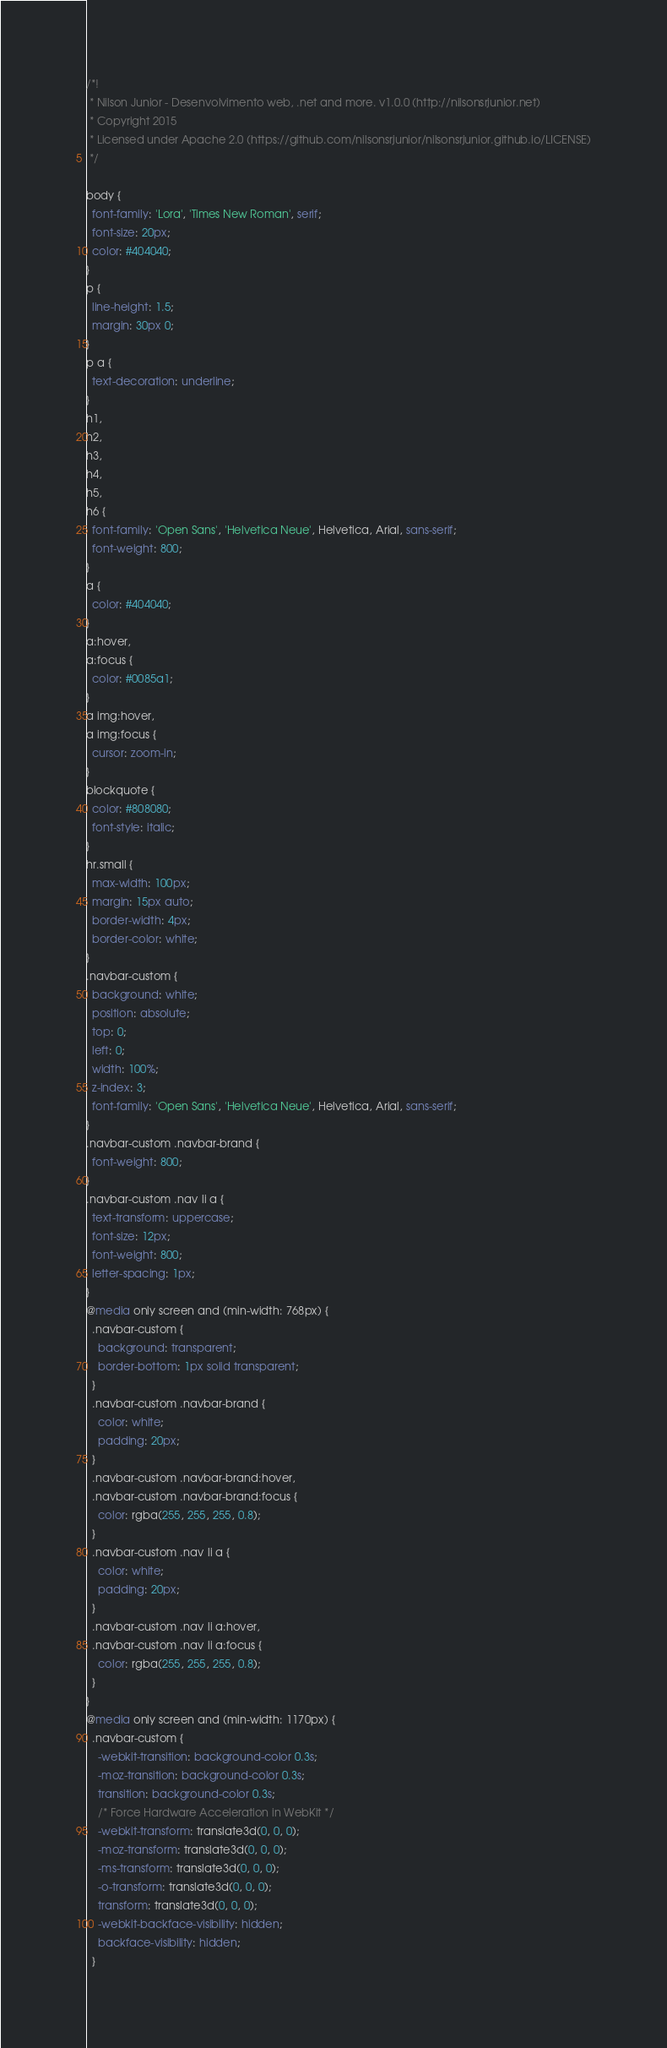<code> <loc_0><loc_0><loc_500><loc_500><_CSS_>/*!
 * Nilson Junior - Desenvolvimento web, .net and more. v1.0.0 (http://nilsonsrjunior.net)
 * Copyright 2015 
 * Licensed under Apache 2.0 (https://github.com/nilsonsrjunior/nilsonsrjunior.github.io/LICENSE)
 */

body {
  font-family: 'Lora', 'Times New Roman', serif;
  font-size: 20px;
  color: #404040;
}
p {
  line-height: 1.5;
  margin: 30px 0;
}
p a {
  text-decoration: underline;
}
h1,
h2,
h3,
h4,
h5,
h6 {
  font-family: 'Open Sans', 'Helvetica Neue', Helvetica, Arial, sans-serif;
  font-weight: 800;
}
a {
  color: #404040;
}
a:hover,
a:focus {
  color: #0085a1;
}
a img:hover,
a img:focus {
  cursor: zoom-in;
}
blockquote {
  color: #808080;
  font-style: italic;
}
hr.small {
  max-width: 100px;
  margin: 15px auto;
  border-width: 4px;
  border-color: white;
}
.navbar-custom {
  background: white;
  position: absolute;
  top: 0;
  left: 0;
  width: 100%;
  z-index: 3;
  font-family: 'Open Sans', 'Helvetica Neue', Helvetica, Arial, sans-serif;
}
.navbar-custom .navbar-brand {
  font-weight: 800;
}
.navbar-custom .nav li a {
  text-transform: uppercase;
  font-size: 12px;
  font-weight: 800;
  letter-spacing: 1px;
}
@media only screen and (min-width: 768px) {
  .navbar-custom {
    background: transparent;
    border-bottom: 1px solid transparent;
  }
  .navbar-custom .navbar-brand {
    color: white;
    padding: 20px;
  }
  .navbar-custom .navbar-brand:hover,
  .navbar-custom .navbar-brand:focus {
    color: rgba(255, 255, 255, 0.8);
  }
  .navbar-custom .nav li a {
    color: white;
    padding: 20px;
  }
  .navbar-custom .nav li a:hover,
  .navbar-custom .nav li a:focus {
    color: rgba(255, 255, 255, 0.8);
  }
}
@media only screen and (min-width: 1170px) {
  .navbar-custom {
    -webkit-transition: background-color 0.3s;
    -moz-transition: background-color 0.3s;
    transition: background-color 0.3s;
    /* Force Hardware Acceleration in WebKit */
    -webkit-transform: translate3d(0, 0, 0);
    -moz-transform: translate3d(0, 0, 0);
    -ms-transform: translate3d(0, 0, 0);
    -o-transform: translate3d(0, 0, 0);
    transform: translate3d(0, 0, 0);
    -webkit-backface-visibility: hidden;
    backface-visibility: hidden;
  }</code> 